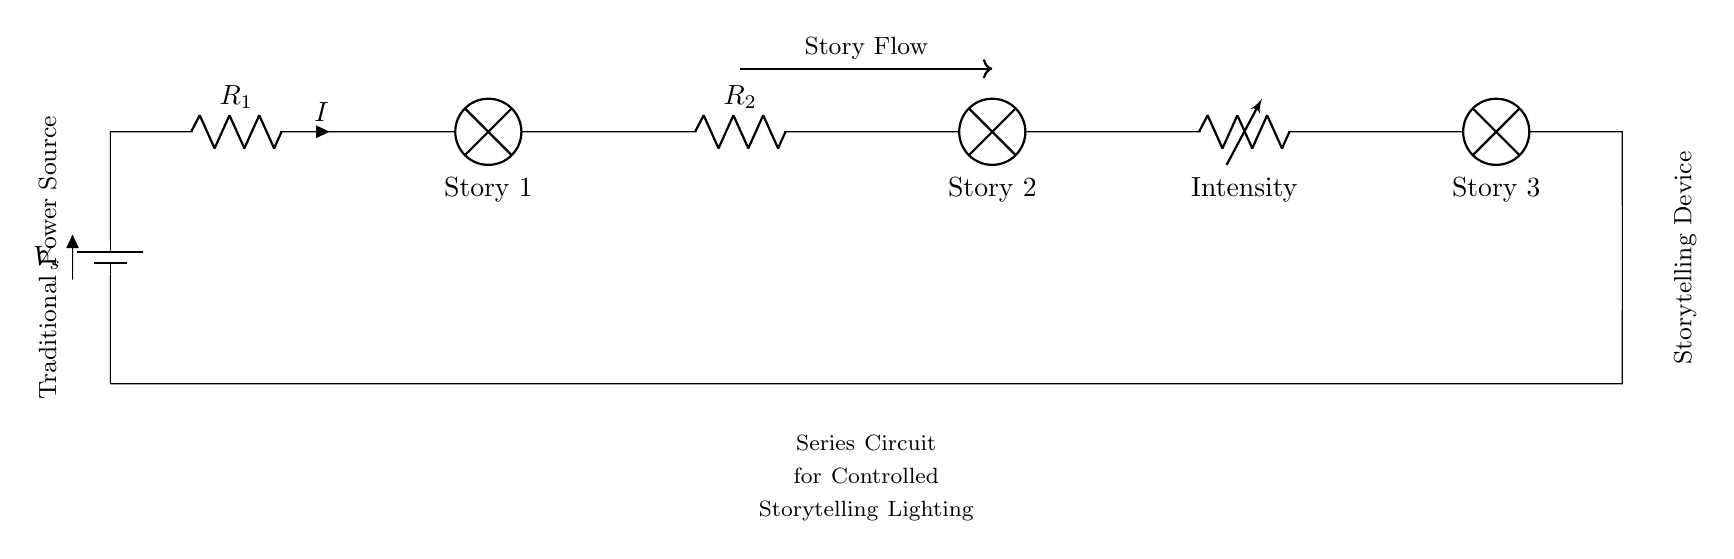What components are in this circuit? The circuit includes a battery, two resistors, three lamps, and a variable resistor. Together, they form components that manage the flow and intensity of storytelling light.
Answer: battery, resistors, lamps What is the purpose of the variable resistor? The variable resistor is used to control the intensity of the light emitted by the lamps, allowing for adjustment based on the storytelling needs.
Answer: control light intensity How many stories are represented in the diagram? There are three lamps representing three distinct stories in this series circuit, each contributing to the overall storytelling experience.
Answer: three stories What type of circuit is shown in the diagram? The circuit is a series circuit where all components are connected end-to-end, creating a single path for current to flow through all of them.
Answer: series circuit If one lamp burns out, what happens to the others? In a series circuit, if one lamp fails, the entire circuit is interrupted, and all lamps will stop illuminating because there is no complete path for current flow.
Answer: all lamps go out What does the arrow labeled "Story Flow" indicate? The arrow signifies the direction of narrative progression through the stories, showcasing how the tales are connected in a sequential manner, reflecting the circuit design.
Answer: narrative direction 